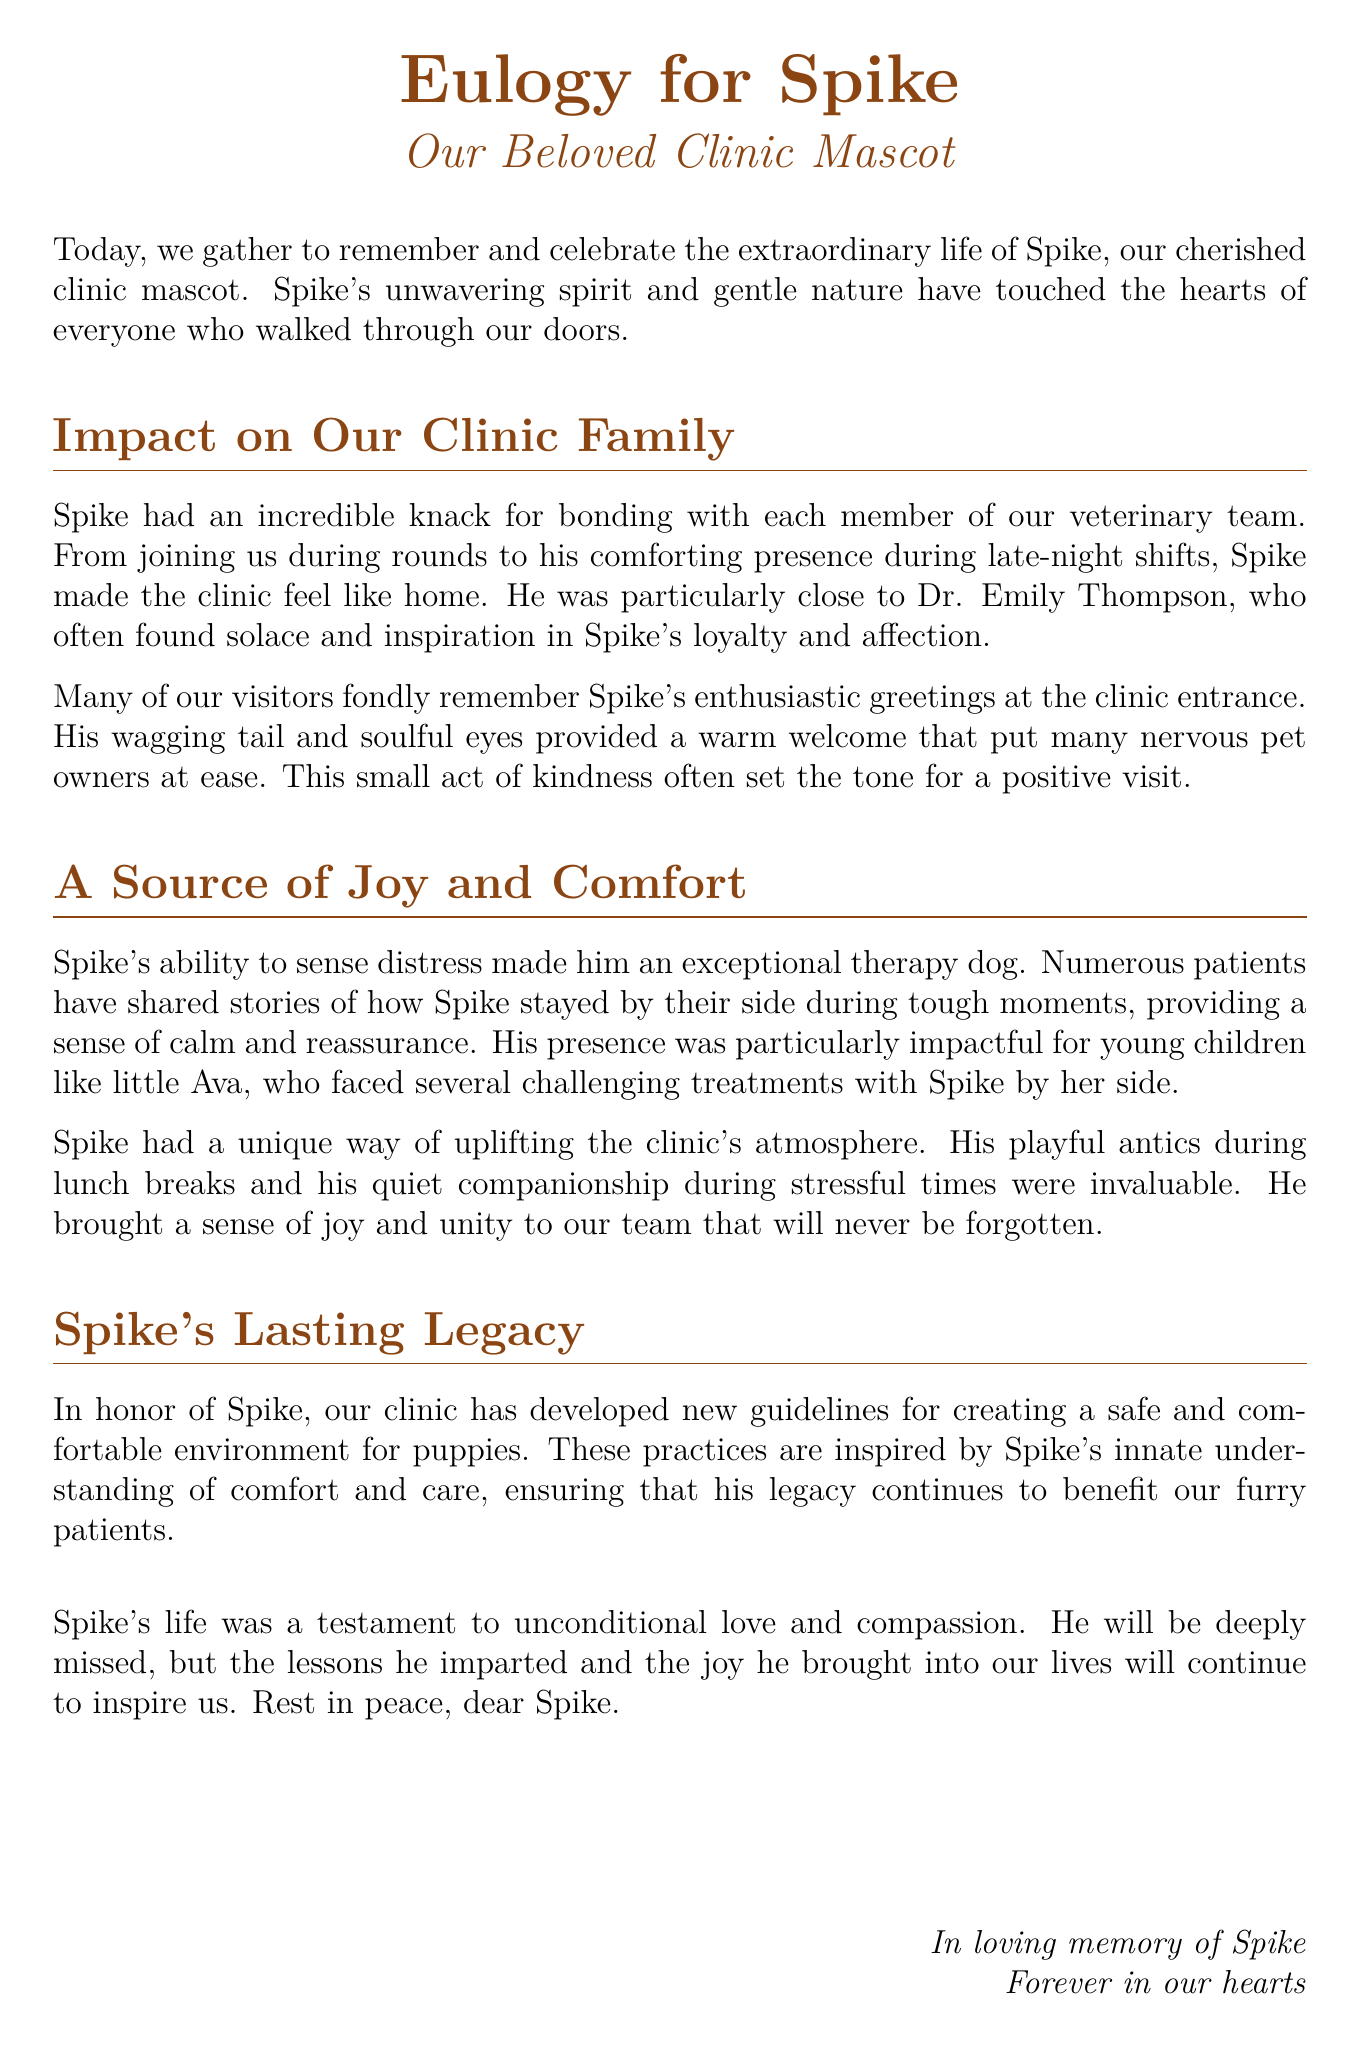What was Spike's role in the clinic? Spike served as the beloved clinic mascot, providing comfort and joy to staff and visitors.
Answer: Clinic mascot Who was particularly close to Spike? Dr. Emily Thompson had a special bond with Spike, often finding solace in his company.
Answer: Dr. Emily Thompson What did many visitors remember about Spike? Visitors fondly recalled Spike's enthusiastic greetings at the clinic entrance.
Answer: Enthusiastic greetings How did Spike contribute to patient comfort? Spike stayed by patients' sides during tough moments, providing calm and reassurance.
Answer: Calm and reassurance What changes did the clinic make in Spike's honor? The clinic developed new guidelines for creating a safe and comfortable environment for puppies.
Answer: New guidelines What quality made Spike an exceptional therapy dog? Spike's ability to sense distress made him an exceptional therapy dog.
Answer: Sense of distress What was Spike's presence particularly impactful for? Spike's presence was particularly impactful for young children facing challenging treatments.
Answer: Young children What type of atmosphere did Spike uplift? Spike uplifted the clinic's atmosphere through his playful antics and companionship.
Answer: Clinic's atmosphere 